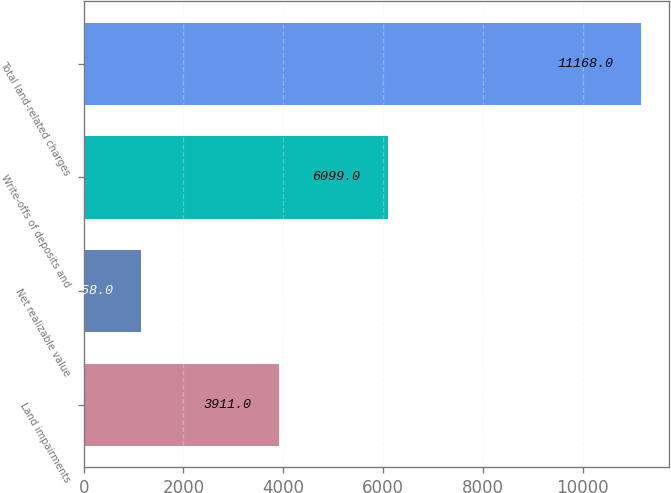Convert chart to OTSL. <chart><loc_0><loc_0><loc_500><loc_500><bar_chart><fcel>Land impairments<fcel>Net realizable value<fcel>Write-offs of deposits and<fcel>Total land-related charges<nl><fcel>3911<fcel>1158<fcel>6099<fcel>11168<nl></chart> 